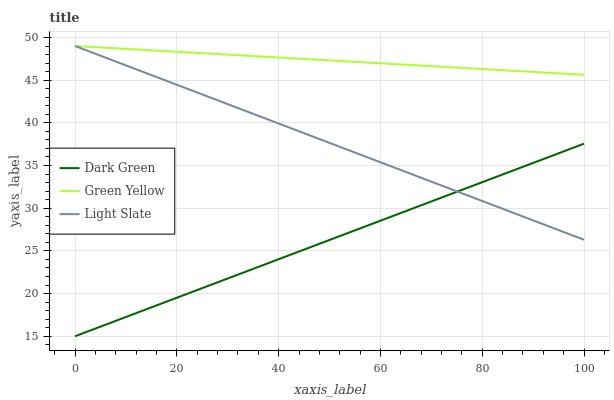Does Dark Green have the minimum area under the curve?
Answer yes or no. Yes. Does Green Yellow have the maximum area under the curve?
Answer yes or no. Yes. Does Green Yellow have the minimum area under the curve?
Answer yes or no. No. Does Dark Green have the maximum area under the curve?
Answer yes or no. No. Is Dark Green the smoothest?
Answer yes or no. Yes. Is Green Yellow the roughest?
Answer yes or no. Yes. Is Green Yellow the smoothest?
Answer yes or no. No. Is Dark Green the roughest?
Answer yes or no. No. Does Dark Green have the lowest value?
Answer yes or no. Yes. Does Green Yellow have the lowest value?
Answer yes or no. No. Does Green Yellow have the highest value?
Answer yes or no. Yes. Does Dark Green have the highest value?
Answer yes or no. No. Is Dark Green less than Green Yellow?
Answer yes or no. Yes. Is Green Yellow greater than Dark Green?
Answer yes or no. Yes. Does Green Yellow intersect Light Slate?
Answer yes or no. Yes. Is Green Yellow less than Light Slate?
Answer yes or no. No. Is Green Yellow greater than Light Slate?
Answer yes or no. No. Does Dark Green intersect Green Yellow?
Answer yes or no. No. 